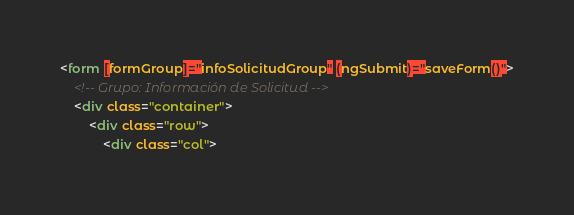<code> <loc_0><loc_0><loc_500><loc_500><_HTML_><form [formGroup]="infoSolicitudGroup" (ngSubmit)="saveForm()">
    <!-- Grupo: Información de Solicitud -->
    <div class="container">
        <div class="row">
            <div class="col"></code> 